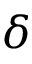Convert formula to latex. <formula><loc_0><loc_0><loc_500><loc_500>\delta</formula> 